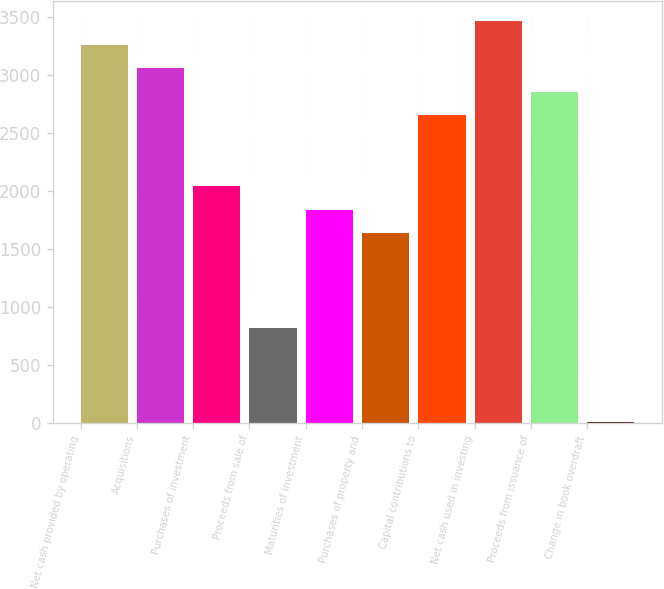<chart> <loc_0><loc_0><loc_500><loc_500><bar_chart><fcel>Net cash provided by operating<fcel>Acquisitions<fcel>Purchases of investment<fcel>Proceeds from sale of<fcel>Maturities of investment<fcel>Purchases of property and<fcel>Capital contributions to<fcel>Net cash used in investing<fcel>Proceeds from issuance of<fcel>Change in book overdraft<nl><fcel>3264.6<fcel>3061<fcel>2043<fcel>821.4<fcel>1839.4<fcel>1635.8<fcel>2653.8<fcel>3468.2<fcel>2857.4<fcel>7<nl></chart> 